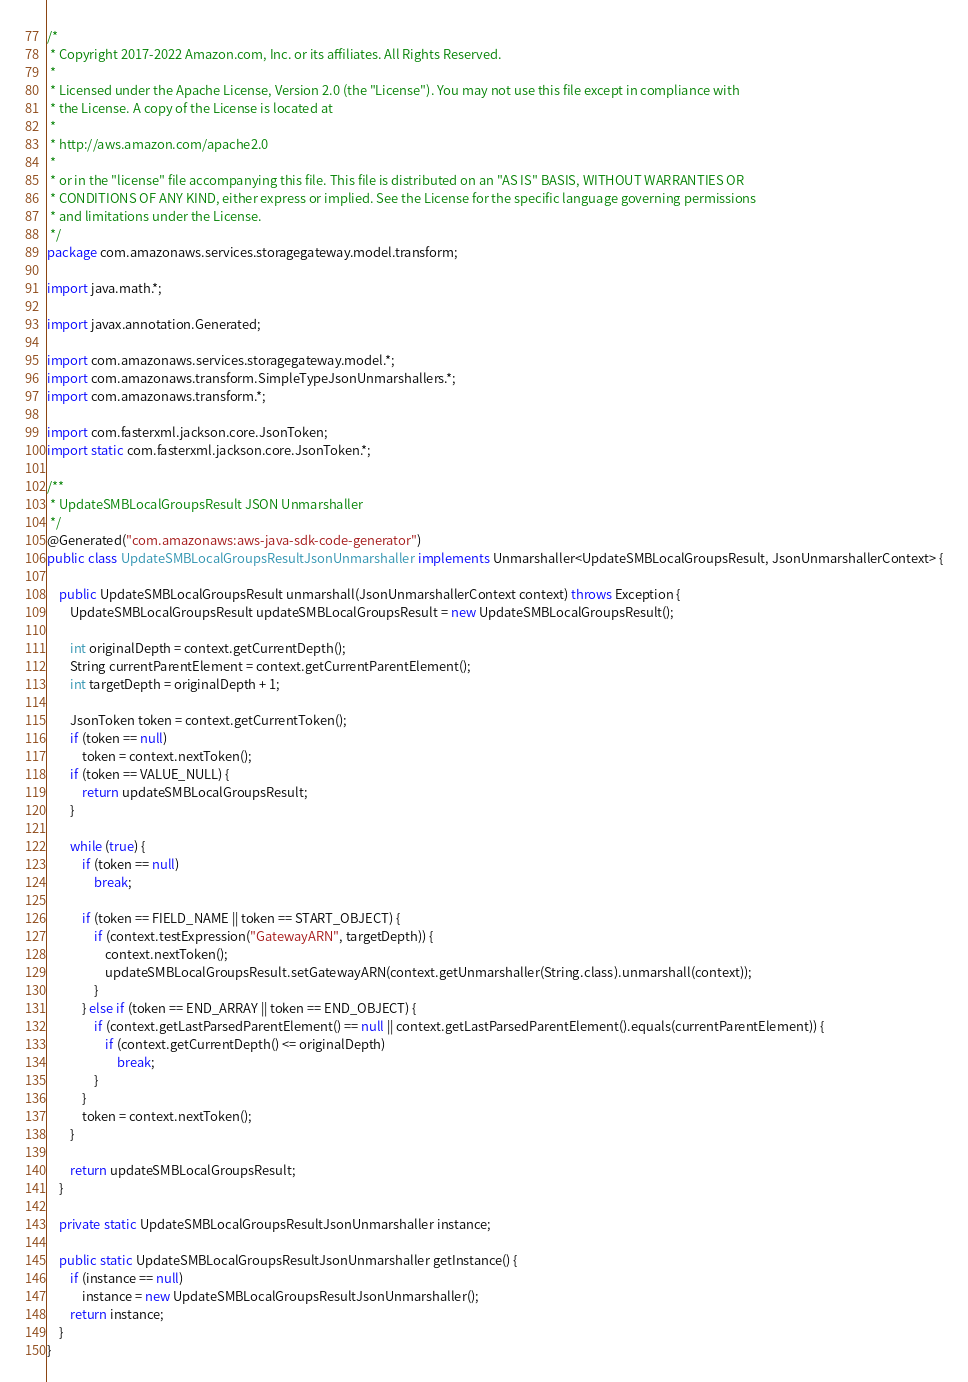<code> <loc_0><loc_0><loc_500><loc_500><_Java_>/*
 * Copyright 2017-2022 Amazon.com, Inc. or its affiliates. All Rights Reserved.
 * 
 * Licensed under the Apache License, Version 2.0 (the "License"). You may not use this file except in compliance with
 * the License. A copy of the License is located at
 * 
 * http://aws.amazon.com/apache2.0
 * 
 * or in the "license" file accompanying this file. This file is distributed on an "AS IS" BASIS, WITHOUT WARRANTIES OR
 * CONDITIONS OF ANY KIND, either express or implied. See the License for the specific language governing permissions
 * and limitations under the License.
 */
package com.amazonaws.services.storagegateway.model.transform;

import java.math.*;

import javax.annotation.Generated;

import com.amazonaws.services.storagegateway.model.*;
import com.amazonaws.transform.SimpleTypeJsonUnmarshallers.*;
import com.amazonaws.transform.*;

import com.fasterxml.jackson.core.JsonToken;
import static com.fasterxml.jackson.core.JsonToken.*;

/**
 * UpdateSMBLocalGroupsResult JSON Unmarshaller
 */
@Generated("com.amazonaws:aws-java-sdk-code-generator")
public class UpdateSMBLocalGroupsResultJsonUnmarshaller implements Unmarshaller<UpdateSMBLocalGroupsResult, JsonUnmarshallerContext> {

    public UpdateSMBLocalGroupsResult unmarshall(JsonUnmarshallerContext context) throws Exception {
        UpdateSMBLocalGroupsResult updateSMBLocalGroupsResult = new UpdateSMBLocalGroupsResult();

        int originalDepth = context.getCurrentDepth();
        String currentParentElement = context.getCurrentParentElement();
        int targetDepth = originalDepth + 1;

        JsonToken token = context.getCurrentToken();
        if (token == null)
            token = context.nextToken();
        if (token == VALUE_NULL) {
            return updateSMBLocalGroupsResult;
        }

        while (true) {
            if (token == null)
                break;

            if (token == FIELD_NAME || token == START_OBJECT) {
                if (context.testExpression("GatewayARN", targetDepth)) {
                    context.nextToken();
                    updateSMBLocalGroupsResult.setGatewayARN(context.getUnmarshaller(String.class).unmarshall(context));
                }
            } else if (token == END_ARRAY || token == END_OBJECT) {
                if (context.getLastParsedParentElement() == null || context.getLastParsedParentElement().equals(currentParentElement)) {
                    if (context.getCurrentDepth() <= originalDepth)
                        break;
                }
            }
            token = context.nextToken();
        }

        return updateSMBLocalGroupsResult;
    }

    private static UpdateSMBLocalGroupsResultJsonUnmarshaller instance;

    public static UpdateSMBLocalGroupsResultJsonUnmarshaller getInstance() {
        if (instance == null)
            instance = new UpdateSMBLocalGroupsResultJsonUnmarshaller();
        return instance;
    }
}
</code> 